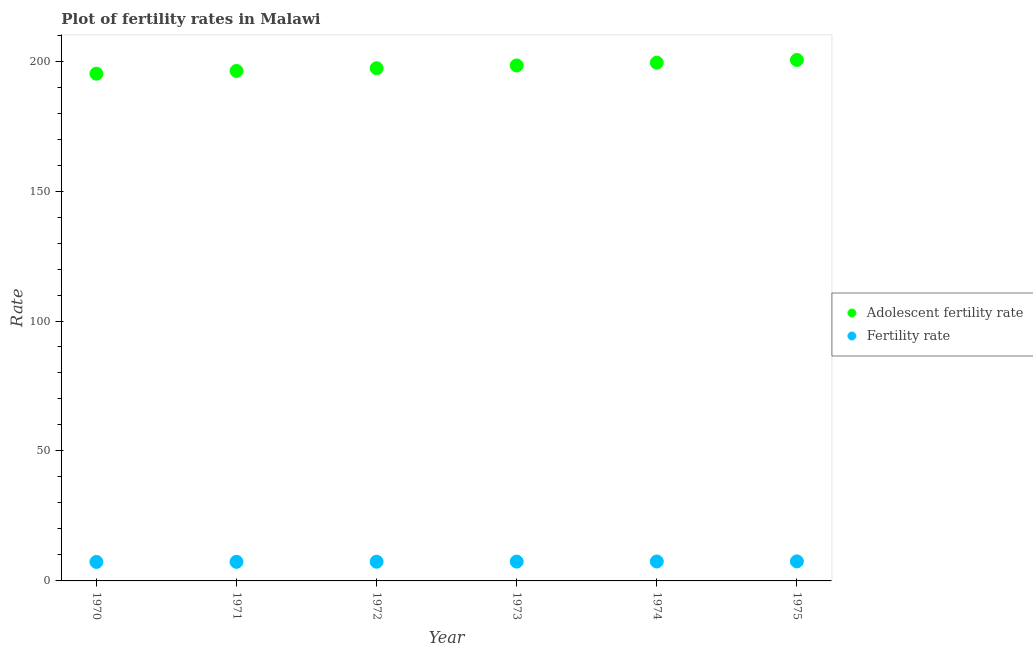How many different coloured dotlines are there?
Offer a very short reply. 2. What is the fertility rate in 1973?
Make the answer very short. 7.43. Across all years, what is the maximum fertility rate?
Provide a succinct answer. 7.52. Across all years, what is the minimum fertility rate?
Offer a very short reply. 7.3. In which year was the adolescent fertility rate maximum?
Ensure brevity in your answer.  1975. In which year was the adolescent fertility rate minimum?
Offer a very short reply. 1970. What is the total fertility rate in the graph?
Ensure brevity in your answer.  44.46. What is the difference between the fertility rate in 1971 and that in 1974?
Keep it short and to the point. -0.13. What is the difference between the adolescent fertility rate in 1974 and the fertility rate in 1970?
Ensure brevity in your answer.  192.07. What is the average adolescent fertility rate per year?
Your response must be concise. 197.79. In the year 1975, what is the difference between the fertility rate and adolescent fertility rate?
Your response must be concise. -192.91. What is the ratio of the fertility rate in 1972 to that in 1975?
Give a very brief answer. 0.98. Is the adolescent fertility rate in 1973 less than that in 1975?
Your response must be concise. Yes. What is the difference between the highest and the second highest adolescent fertility rate?
Provide a succinct answer. 1.06. What is the difference between the highest and the lowest fertility rate?
Offer a terse response. 0.21. In how many years, is the fertility rate greater than the average fertility rate taken over all years?
Provide a short and direct response. 3. Is the fertility rate strictly greater than the adolescent fertility rate over the years?
Offer a terse response. No. Is the adolescent fertility rate strictly less than the fertility rate over the years?
Ensure brevity in your answer.  No. Does the graph contain any zero values?
Give a very brief answer. No. How many legend labels are there?
Your answer should be very brief. 2. How are the legend labels stacked?
Provide a short and direct response. Vertical. What is the title of the graph?
Your answer should be very brief. Plot of fertility rates in Malawi. Does "Frequency of shipment arrival" appear as one of the legend labels in the graph?
Offer a very short reply. No. What is the label or title of the X-axis?
Provide a succinct answer. Year. What is the label or title of the Y-axis?
Offer a very short reply. Rate. What is the Rate in Adolescent fertility rate in 1970?
Offer a terse response. 195.15. What is the Rate in Fertility rate in 1970?
Give a very brief answer. 7.3. What is the Rate in Adolescent fertility rate in 1971?
Make the answer very short. 196.2. What is the Rate of Fertility rate in 1971?
Provide a succinct answer. 7.34. What is the Rate of Adolescent fertility rate in 1972?
Your answer should be compact. 197.26. What is the Rate of Fertility rate in 1972?
Ensure brevity in your answer.  7.39. What is the Rate of Adolescent fertility rate in 1973?
Your response must be concise. 198.31. What is the Rate in Fertility rate in 1973?
Your response must be concise. 7.43. What is the Rate of Adolescent fertility rate in 1974?
Provide a succinct answer. 199.37. What is the Rate in Fertility rate in 1974?
Your answer should be very brief. 7.48. What is the Rate of Adolescent fertility rate in 1975?
Keep it short and to the point. 200.43. What is the Rate of Fertility rate in 1975?
Keep it short and to the point. 7.52. Across all years, what is the maximum Rate of Adolescent fertility rate?
Your answer should be very brief. 200.43. Across all years, what is the maximum Rate of Fertility rate?
Ensure brevity in your answer.  7.52. Across all years, what is the minimum Rate of Adolescent fertility rate?
Provide a short and direct response. 195.15. Across all years, what is the minimum Rate of Fertility rate?
Ensure brevity in your answer.  7.3. What is the total Rate of Adolescent fertility rate in the graph?
Offer a terse response. 1186.72. What is the total Rate in Fertility rate in the graph?
Your response must be concise. 44.46. What is the difference between the Rate of Adolescent fertility rate in 1970 and that in 1971?
Offer a very short reply. -1.06. What is the difference between the Rate of Fertility rate in 1970 and that in 1971?
Keep it short and to the point. -0.04. What is the difference between the Rate in Adolescent fertility rate in 1970 and that in 1972?
Offer a terse response. -2.11. What is the difference between the Rate of Fertility rate in 1970 and that in 1972?
Provide a succinct answer. -0.09. What is the difference between the Rate in Adolescent fertility rate in 1970 and that in 1973?
Your response must be concise. -3.17. What is the difference between the Rate in Fertility rate in 1970 and that in 1973?
Offer a terse response. -0.13. What is the difference between the Rate of Adolescent fertility rate in 1970 and that in 1974?
Offer a terse response. -4.22. What is the difference between the Rate of Fertility rate in 1970 and that in 1974?
Give a very brief answer. -0.17. What is the difference between the Rate in Adolescent fertility rate in 1970 and that in 1975?
Your response must be concise. -5.28. What is the difference between the Rate of Fertility rate in 1970 and that in 1975?
Make the answer very short. -0.21. What is the difference between the Rate of Adolescent fertility rate in 1971 and that in 1972?
Offer a very short reply. -1.06. What is the difference between the Rate of Fertility rate in 1971 and that in 1972?
Offer a terse response. -0.04. What is the difference between the Rate in Adolescent fertility rate in 1971 and that in 1973?
Provide a short and direct response. -2.11. What is the difference between the Rate in Fertility rate in 1971 and that in 1973?
Provide a succinct answer. -0.09. What is the difference between the Rate of Adolescent fertility rate in 1971 and that in 1974?
Your response must be concise. -3.17. What is the difference between the Rate in Fertility rate in 1971 and that in 1974?
Offer a very short reply. -0.13. What is the difference between the Rate in Adolescent fertility rate in 1971 and that in 1975?
Offer a very short reply. -4.22. What is the difference between the Rate in Fertility rate in 1971 and that in 1975?
Give a very brief answer. -0.17. What is the difference between the Rate in Adolescent fertility rate in 1972 and that in 1973?
Your answer should be very brief. -1.06. What is the difference between the Rate of Fertility rate in 1972 and that in 1973?
Offer a terse response. -0.04. What is the difference between the Rate of Adolescent fertility rate in 1972 and that in 1974?
Ensure brevity in your answer.  -2.11. What is the difference between the Rate of Fertility rate in 1972 and that in 1974?
Provide a short and direct response. -0.09. What is the difference between the Rate in Adolescent fertility rate in 1972 and that in 1975?
Make the answer very short. -3.17. What is the difference between the Rate of Fertility rate in 1972 and that in 1975?
Provide a succinct answer. -0.13. What is the difference between the Rate in Adolescent fertility rate in 1973 and that in 1974?
Offer a terse response. -1.06. What is the difference between the Rate of Fertility rate in 1973 and that in 1974?
Provide a succinct answer. -0.04. What is the difference between the Rate in Adolescent fertility rate in 1973 and that in 1975?
Keep it short and to the point. -2.11. What is the difference between the Rate in Fertility rate in 1973 and that in 1975?
Your answer should be very brief. -0.09. What is the difference between the Rate of Adolescent fertility rate in 1974 and that in 1975?
Your response must be concise. -1.06. What is the difference between the Rate of Fertility rate in 1974 and that in 1975?
Ensure brevity in your answer.  -0.04. What is the difference between the Rate in Adolescent fertility rate in 1970 and the Rate in Fertility rate in 1971?
Your answer should be compact. 187.8. What is the difference between the Rate of Adolescent fertility rate in 1970 and the Rate of Fertility rate in 1972?
Offer a very short reply. 187.76. What is the difference between the Rate of Adolescent fertility rate in 1970 and the Rate of Fertility rate in 1973?
Give a very brief answer. 187.72. What is the difference between the Rate in Adolescent fertility rate in 1970 and the Rate in Fertility rate in 1974?
Your answer should be very brief. 187.67. What is the difference between the Rate in Adolescent fertility rate in 1970 and the Rate in Fertility rate in 1975?
Provide a succinct answer. 187.63. What is the difference between the Rate of Adolescent fertility rate in 1971 and the Rate of Fertility rate in 1972?
Provide a succinct answer. 188.81. What is the difference between the Rate of Adolescent fertility rate in 1971 and the Rate of Fertility rate in 1973?
Offer a terse response. 188.77. What is the difference between the Rate of Adolescent fertility rate in 1971 and the Rate of Fertility rate in 1974?
Keep it short and to the point. 188.73. What is the difference between the Rate in Adolescent fertility rate in 1971 and the Rate in Fertility rate in 1975?
Offer a terse response. 188.69. What is the difference between the Rate of Adolescent fertility rate in 1972 and the Rate of Fertility rate in 1973?
Ensure brevity in your answer.  189.83. What is the difference between the Rate in Adolescent fertility rate in 1972 and the Rate in Fertility rate in 1974?
Offer a terse response. 189.78. What is the difference between the Rate in Adolescent fertility rate in 1972 and the Rate in Fertility rate in 1975?
Your answer should be very brief. 189.74. What is the difference between the Rate in Adolescent fertility rate in 1973 and the Rate in Fertility rate in 1974?
Make the answer very short. 190.84. What is the difference between the Rate in Adolescent fertility rate in 1973 and the Rate in Fertility rate in 1975?
Make the answer very short. 190.8. What is the difference between the Rate in Adolescent fertility rate in 1974 and the Rate in Fertility rate in 1975?
Provide a succinct answer. 191.85. What is the average Rate in Adolescent fertility rate per year?
Ensure brevity in your answer.  197.79. What is the average Rate of Fertility rate per year?
Ensure brevity in your answer.  7.41. In the year 1970, what is the difference between the Rate in Adolescent fertility rate and Rate in Fertility rate?
Your answer should be compact. 187.84. In the year 1971, what is the difference between the Rate in Adolescent fertility rate and Rate in Fertility rate?
Offer a terse response. 188.86. In the year 1972, what is the difference between the Rate in Adolescent fertility rate and Rate in Fertility rate?
Give a very brief answer. 189.87. In the year 1973, what is the difference between the Rate of Adolescent fertility rate and Rate of Fertility rate?
Offer a very short reply. 190.88. In the year 1974, what is the difference between the Rate in Adolescent fertility rate and Rate in Fertility rate?
Provide a short and direct response. 191.89. In the year 1975, what is the difference between the Rate in Adolescent fertility rate and Rate in Fertility rate?
Provide a succinct answer. 192.91. What is the ratio of the Rate of Adolescent fertility rate in 1970 to that in 1972?
Your response must be concise. 0.99. What is the ratio of the Rate in Fertility rate in 1970 to that in 1972?
Your answer should be compact. 0.99. What is the ratio of the Rate of Adolescent fertility rate in 1970 to that in 1973?
Provide a succinct answer. 0.98. What is the ratio of the Rate of Fertility rate in 1970 to that in 1973?
Your answer should be very brief. 0.98. What is the ratio of the Rate of Adolescent fertility rate in 1970 to that in 1974?
Keep it short and to the point. 0.98. What is the ratio of the Rate in Fertility rate in 1970 to that in 1974?
Provide a short and direct response. 0.98. What is the ratio of the Rate in Adolescent fertility rate in 1970 to that in 1975?
Give a very brief answer. 0.97. What is the ratio of the Rate of Fertility rate in 1970 to that in 1975?
Your response must be concise. 0.97. What is the ratio of the Rate of Adolescent fertility rate in 1971 to that in 1972?
Offer a terse response. 0.99. What is the ratio of the Rate of Fertility rate in 1971 to that in 1973?
Your answer should be compact. 0.99. What is the ratio of the Rate of Adolescent fertility rate in 1971 to that in 1974?
Provide a short and direct response. 0.98. What is the ratio of the Rate in Fertility rate in 1971 to that in 1974?
Your response must be concise. 0.98. What is the ratio of the Rate in Adolescent fertility rate in 1971 to that in 1975?
Offer a terse response. 0.98. What is the ratio of the Rate in Fertility rate in 1971 to that in 1975?
Keep it short and to the point. 0.98. What is the ratio of the Rate of Adolescent fertility rate in 1972 to that in 1973?
Your response must be concise. 0.99. What is the ratio of the Rate in Fertility rate in 1972 to that in 1973?
Offer a very short reply. 0.99. What is the ratio of the Rate in Fertility rate in 1972 to that in 1974?
Keep it short and to the point. 0.99. What is the ratio of the Rate of Adolescent fertility rate in 1972 to that in 1975?
Keep it short and to the point. 0.98. What is the ratio of the Rate in Fertility rate in 1972 to that in 1975?
Provide a short and direct response. 0.98. What is the ratio of the Rate of Adolescent fertility rate in 1973 to that in 1974?
Your answer should be compact. 0.99. What is the ratio of the Rate of Fertility rate in 1973 to that in 1975?
Provide a short and direct response. 0.99. What is the ratio of the Rate in Fertility rate in 1974 to that in 1975?
Keep it short and to the point. 0.99. What is the difference between the highest and the second highest Rate in Adolescent fertility rate?
Ensure brevity in your answer.  1.06. What is the difference between the highest and the second highest Rate of Fertility rate?
Ensure brevity in your answer.  0.04. What is the difference between the highest and the lowest Rate in Adolescent fertility rate?
Ensure brevity in your answer.  5.28. What is the difference between the highest and the lowest Rate of Fertility rate?
Your answer should be compact. 0.21. 